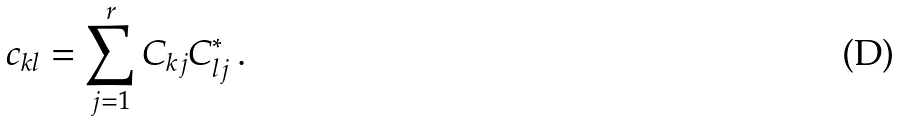<formula> <loc_0><loc_0><loc_500><loc_500>c _ { k l } = \sum _ { j = 1 } ^ { r } C _ { k j } C _ { l j } ^ { * } \, .</formula> 